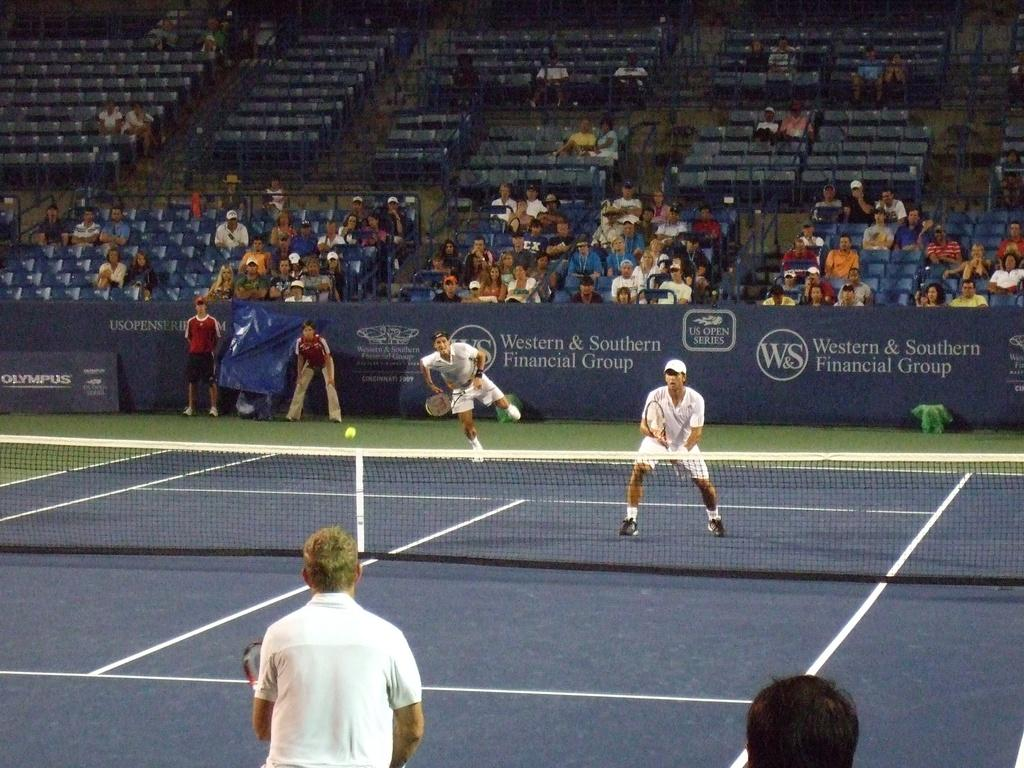Who or what is present in the image? There are people in the image. What are the people doing in the image? The people are standing and holding rackets. What can be seen in the background of the image? There is a stadium and chairs with people in the background of the image. How does the steam escape from the racket in the image? There is no steam present in the image; the people are holding rackets, but they are not associated with steam. 